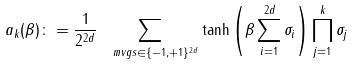Convert formula to latex. <formula><loc_0><loc_0><loc_500><loc_500>a _ { k } ( \beta ) \colon = \frac { 1 } { 2 ^ { 2 d } } \sum _ { \ m v g s \in \{ - 1 , + 1 \} ^ { 2 d } } \tanh \left ( \beta \sum _ { i = 1 } ^ { 2 d } \sigma _ { i } \right ) \prod _ { j = 1 } ^ { k } \sigma _ { j }</formula> 